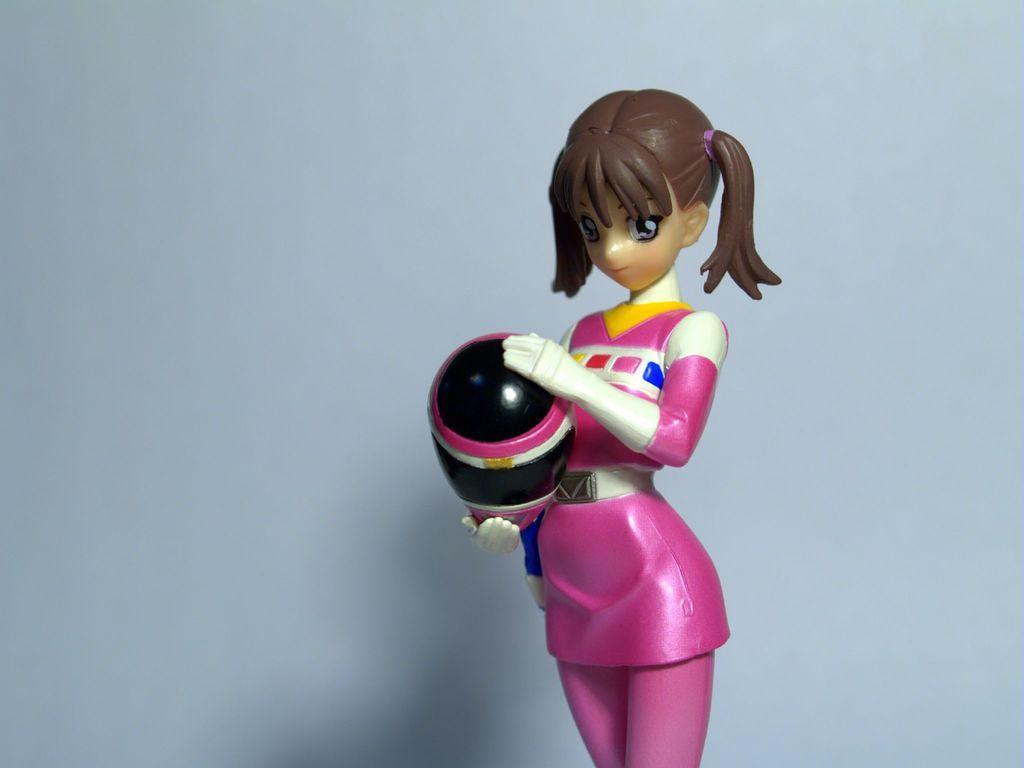Describe this image in one or two sentences. In this image in the center there is one toy girl, and there is white background. 